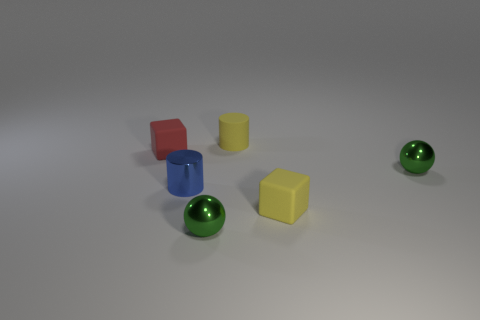Add 1 big yellow cylinders. How many objects exist? 7 Subtract all cubes. How many objects are left? 4 Add 5 green spheres. How many green spheres are left? 7 Add 5 shiny balls. How many shiny balls exist? 7 Subtract 0 brown cylinders. How many objects are left? 6 Subtract all cylinders. Subtract all cylinders. How many objects are left? 2 